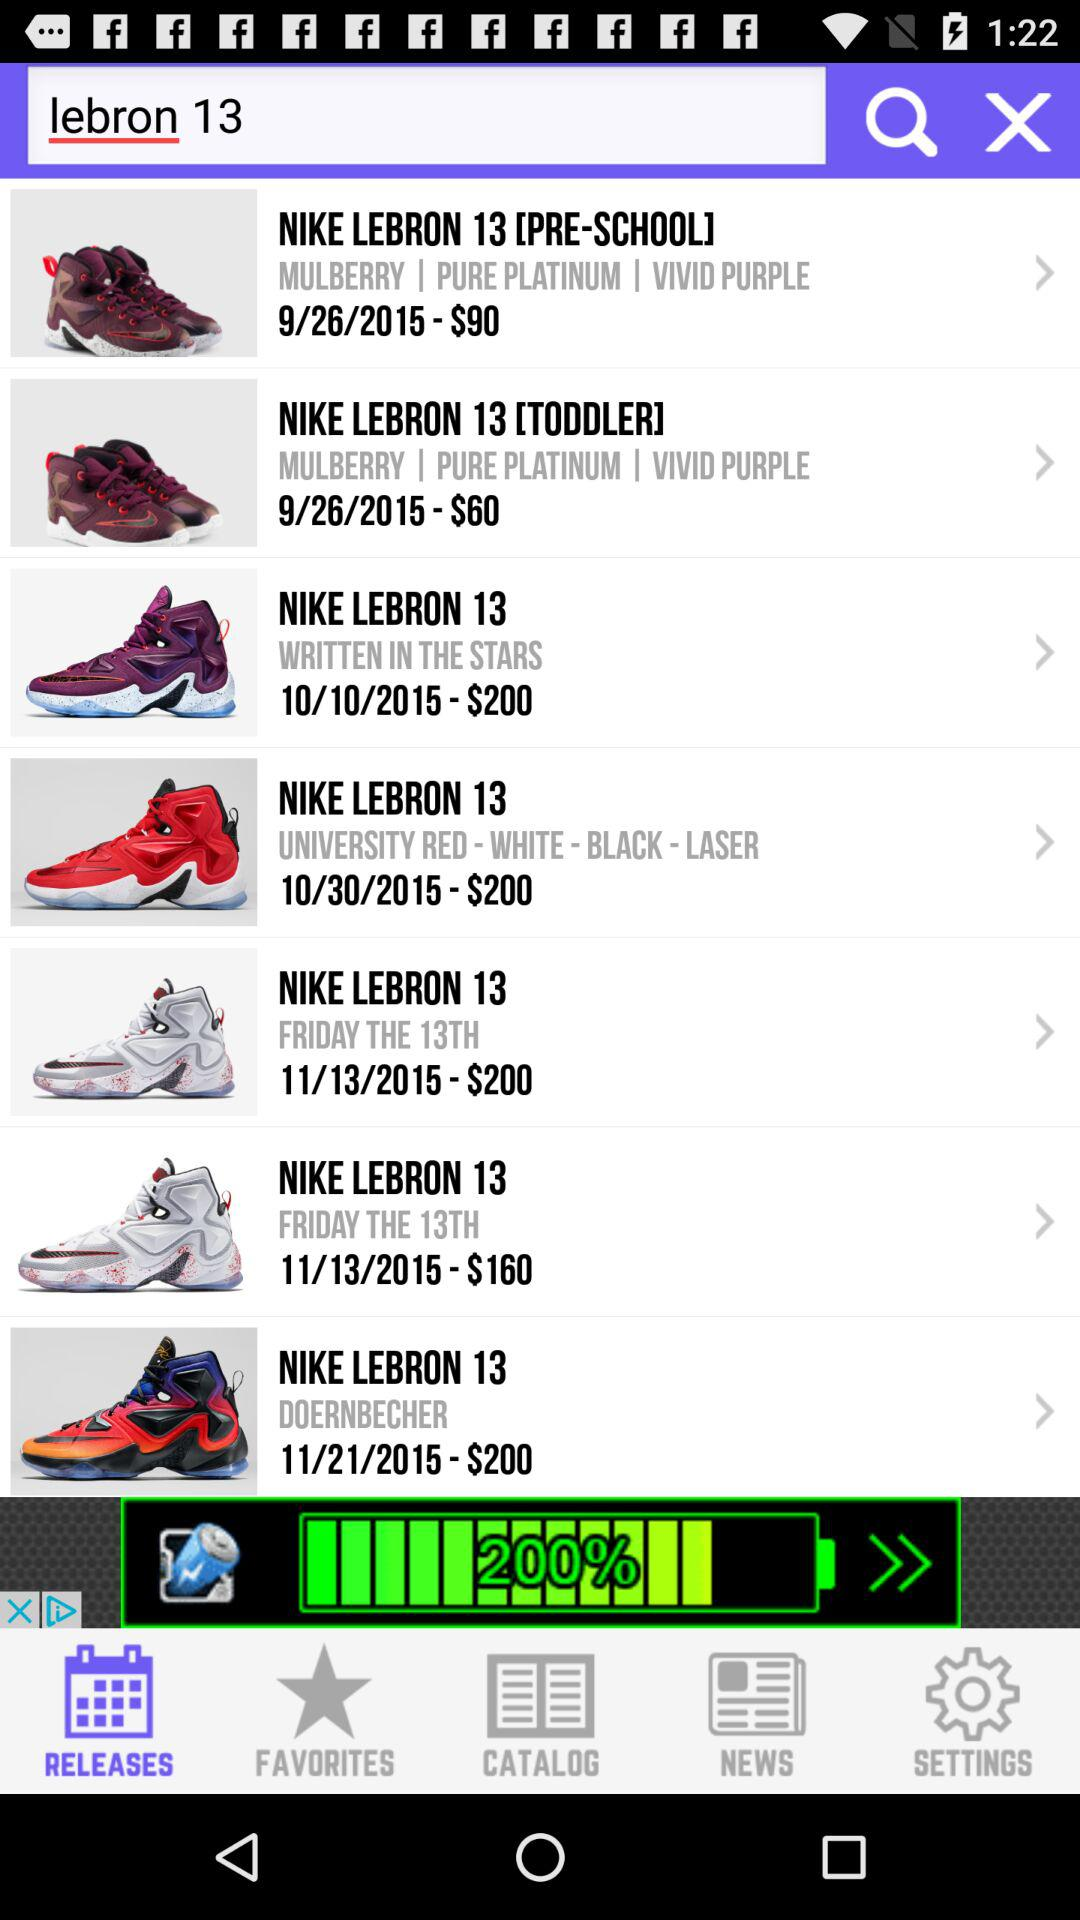What is the date of the "NIKE LEBRON 13 [PRE-SCHOOL]"? The date of the "NIKE LEBRON 13 [PRE-SCHOOL]" is September 26, 2015. 